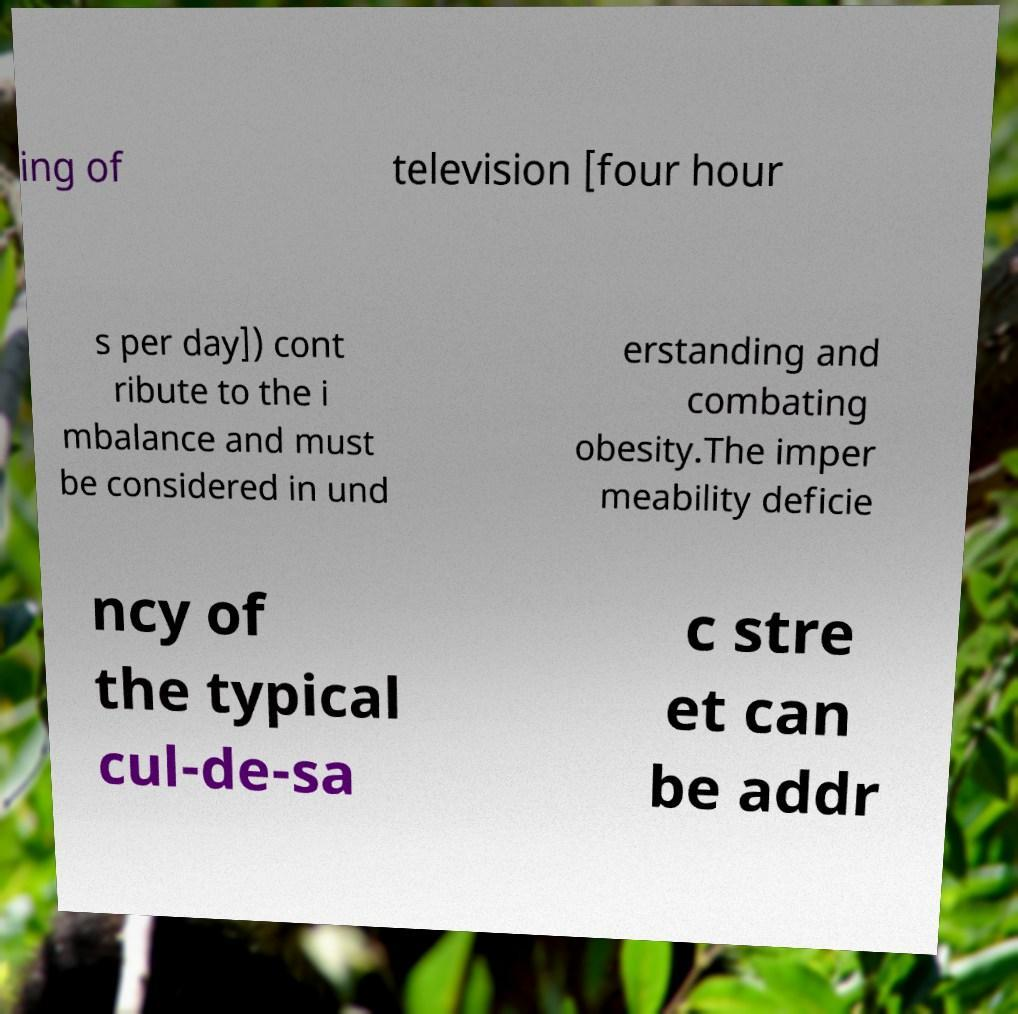What messages or text are displayed in this image? I need them in a readable, typed format. ing of television [four hour s per day]) cont ribute to the i mbalance and must be considered in und erstanding and combating obesity.The imper meability deficie ncy of the typical cul-de-sa c stre et can be addr 